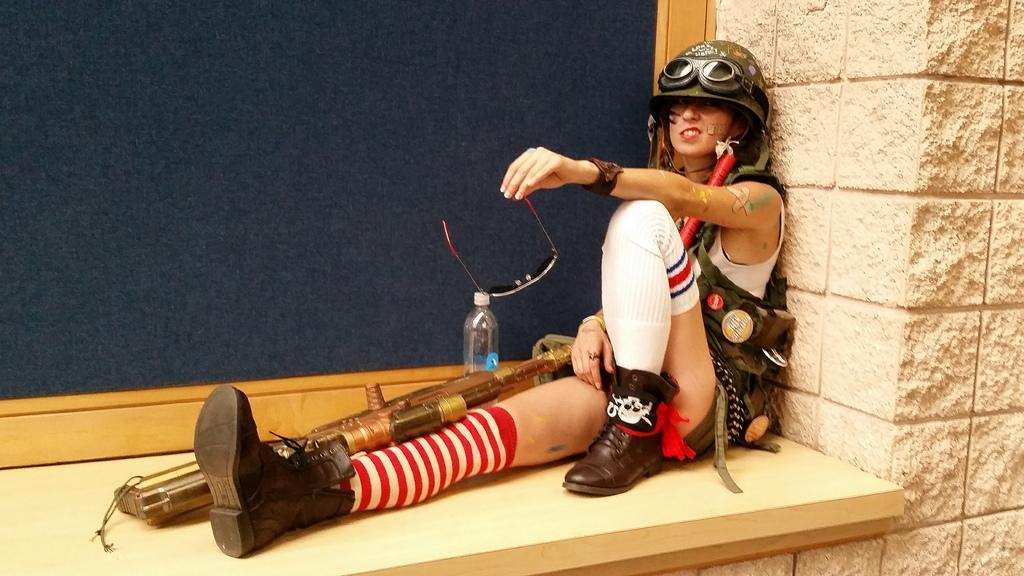What can be seen in the image? There is a person in the image. What is the person wearing? The person is wearing a helmet. What else is the person holding? The person is holding goggles. What is located to the right of the person? There is a bottle to the right of the person. How many ants can be seen crawling on the person's helmet in the image? There are no ants visible in the image, as it only features a person wearing a helmet and holding goggles. 